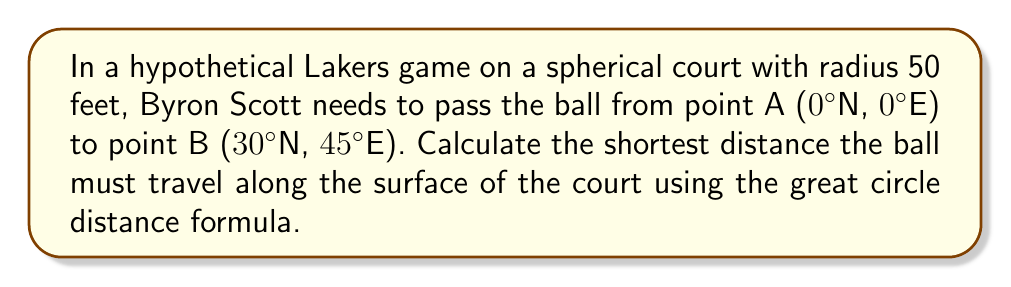Give your solution to this math problem. To solve this problem, we'll use the great circle distance formula:

$$d = R \cdot \arccos(\sin(\phi_1)\sin(\phi_2) + \cos(\phi_1)\cos(\phi_2)\cos(\Delta\lambda))$$

Where:
- $d$ is the distance along the great circle
- $R$ is the radius of the sphere (50 feet in this case)
- $\phi_1$ and $\phi_2$ are the latitudes of points A and B in radians
- $\Delta\lambda$ is the difference in longitude in radians

Step 1: Convert latitudes and longitudes to radians
$\phi_1 = 0° = 0$ radians
$\phi_2 = 30° = \frac{\pi}{6}$ radians
$\Delta\lambda = 45° = \frac{\pi}{4}$ radians

Step 2: Apply the formula
$$\begin{aligned}
d &= 50 \cdot \arccos(\sin(0)\sin(\frac{\pi}{6}) + \cos(0)\cos(\frac{\pi}{6})\cos(\frac{\pi}{4})) \\
&= 50 \cdot \arccos(0 \cdot \frac{1}{2} + 1 \cdot \frac{\sqrt{3}}{2} \cdot \frac{\sqrt{2}}{2}) \\
&= 50 \cdot \arccos(\frac{\sqrt{6}}{4}) \\
&\approx 50 \cdot 0.7297 \\
&\approx 36.49 \text{ feet}
\end{aligned}$$

Therefore, the shortest distance the ball must travel along the surface of the spherical court is approximately 36.49 feet.
Answer: 36.49 feet 